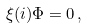<formula> <loc_0><loc_0><loc_500><loc_500>\xi ( i ) \Phi = 0 \, ,</formula> 